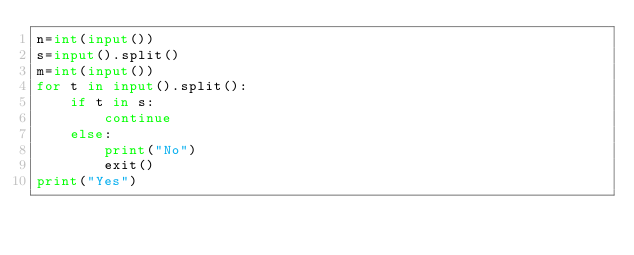<code> <loc_0><loc_0><loc_500><loc_500><_Python_>n=int(input())
s=input().split()
m=int(input())
for t in input().split():
    if t in s:
        continue
    else:
        print("No")
        exit()
print("Yes")</code> 